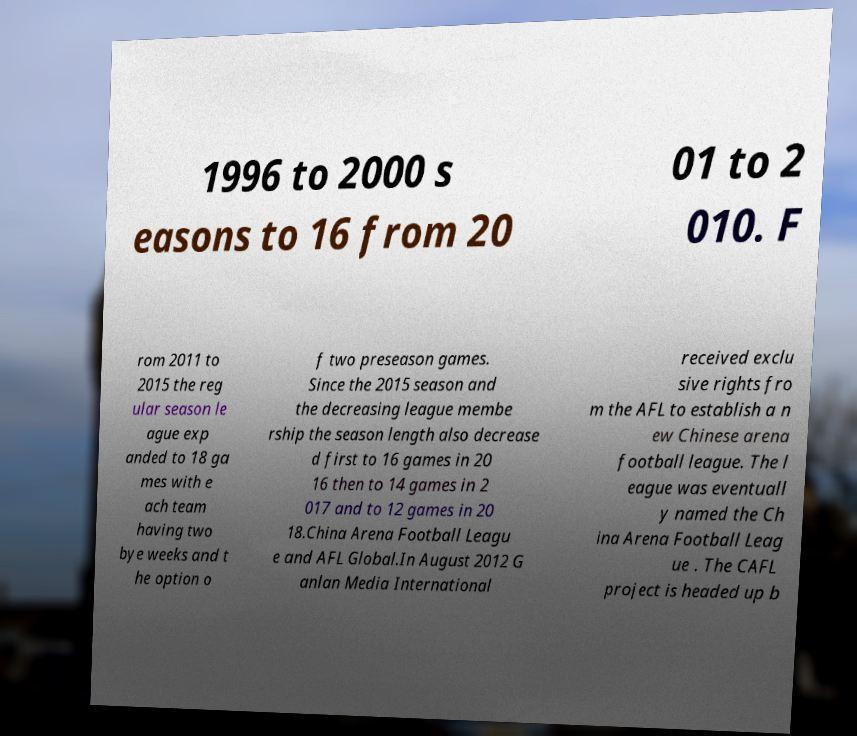I need the written content from this picture converted into text. Can you do that? 1996 to 2000 s easons to 16 from 20 01 to 2 010. F rom 2011 to 2015 the reg ular season le ague exp anded to 18 ga mes with e ach team having two bye weeks and t he option o f two preseason games. Since the 2015 season and the decreasing league membe rship the season length also decrease d first to 16 games in 20 16 then to 14 games in 2 017 and to 12 games in 20 18.China Arena Football Leagu e and AFL Global.In August 2012 G anlan Media International received exclu sive rights fro m the AFL to establish a n ew Chinese arena football league. The l eague was eventuall y named the Ch ina Arena Football Leag ue . The CAFL project is headed up b 